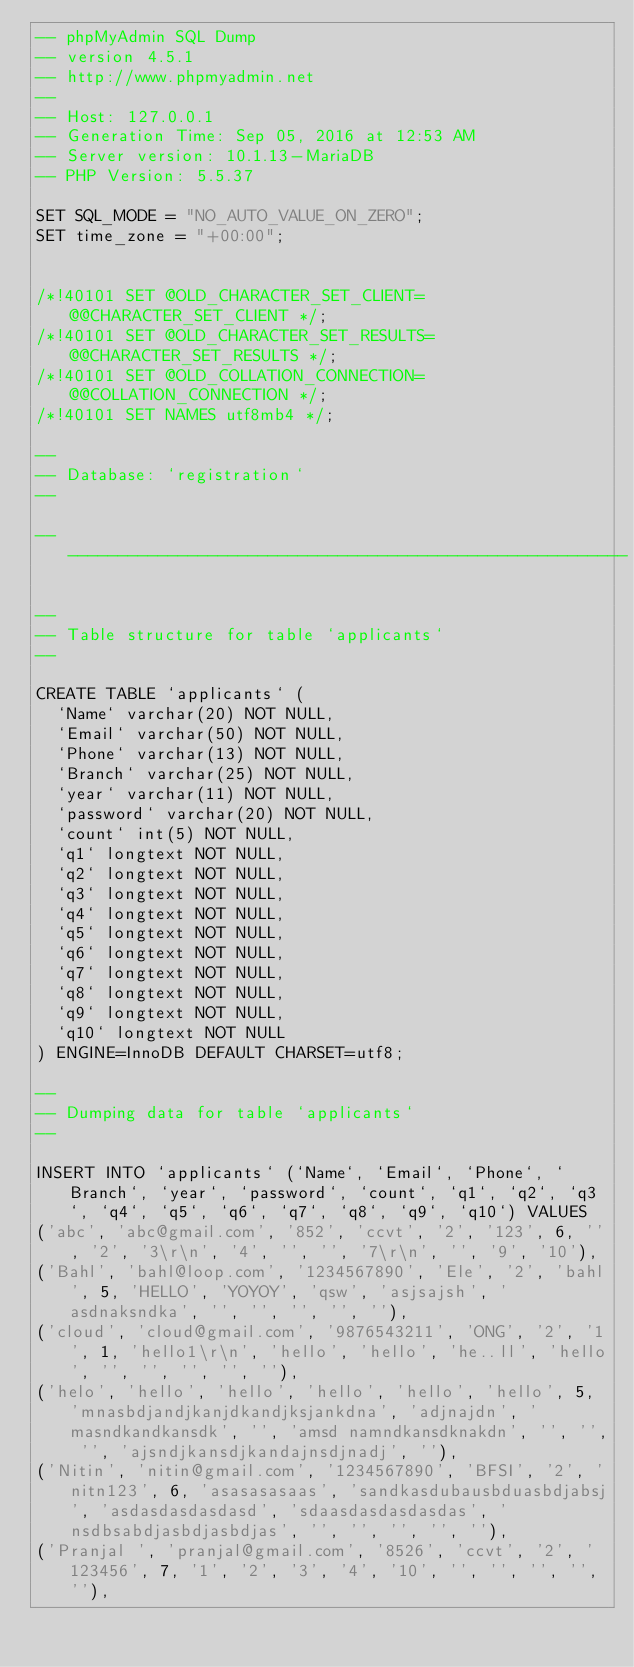Convert code to text. <code><loc_0><loc_0><loc_500><loc_500><_SQL_>-- phpMyAdmin SQL Dump
-- version 4.5.1
-- http://www.phpmyadmin.net
--
-- Host: 127.0.0.1
-- Generation Time: Sep 05, 2016 at 12:53 AM
-- Server version: 10.1.13-MariaDB
-- PHP Version: 5.5.37

SET SQL_MODE = "NO_AUTO_VALUE_ON_ZERO";
SET time_zone = "+00:00";


/*!40101 SET @OLD_CHARACTER_SET_CLIENT=@@CHARACTER_SET_CLIENT */;
/*!40101 SET @OLD_CHARACTER_SET_RESULTS=@@CHARACTER_SET_RESULTS */;
/*!40101 SET @OLD_COLLATION_CONNECTION=@@COLLATION_CONNECTION */;
/*!40101 SET NAMES utf8mb4 */;

--
-- Database: `registration`
--

-- --------------------------------------------------------

--
-- Table structure for table `applicants`
--

CREATE TABLE `applicants` (
  `Name` varchar(20) NOT NULL,
  `Email` varchar(50) NOT NULL,
  `Phone` varchar(13) NOT NULL,
  `Branch` varchar(25) NOT NULL,
  `year` varchar(11) NOT NULL,
  `password` varchar(20) NOT NULL,
  `count` int(5) NOT NULL,
  `q1` longtext NOT NULL,
  `q2` longtext NOT NULL,
  `q3` longtext NOT NULL,
  `q4` longtext NOT NULL,
  `q5` longtext NOT NULL,
  `q6` longtext NOT NULL,
  `q7` longtext NOT NULL,
  `q8` longtext NOT NULL,
  `q9` longtext NOT NULL,
  `q10` longtext NOT NULL
) ENGINE=InnoDB DEFAULT CHARSET=utf8;

--
-- Dumping data for table `applicants`
--

INSERT INTO `applicants` (`Name`, `Email`, `Phone`, `Branch`, `year`, `password`, `count`, `q1`, `q2`, `q3`, `q4`, `q5`, `q6`, `q7`, `q8`, `q9`, `q10`) VALUES
('abc', 'abc@gmail.com', '852', 'ccvt', '2', '123', 6, '', '2', '3\r\n', '4', '', '', '7\r\n', '', '9', '10'),
('Bahl', 'bahl@loop.com', '1234567890', 'Ele', '2', 'bahl', 5, 'HELLO', 'YOYOY', 'qsw', 'asjsajsh', 'asdnaksndka', '', '', '', '', ''),
('cloud', 'cloud@gmail.com', '9876543211', 'ONG', '2', '1', 1, 'hello1\r\n', 'hello', 'hello', 'he..ll', 'hello', '', '', '', '', ''),
('helo', 'hello', 'hello', 'hello', 'hello', 'hello', 5, 'mnasbdjandjkanjdkandjksjankdna', 'adjnajdn', 'masndkandkansdk', '', 'amsd namndkansdknakdn', '', '', '', 'ajsndjkansdjkandajnsdjnadj', ''),
('Nitin', 'nitin@gmail.com', '1234567890', 'BFSI', '2', 'nitn123', 6, 'asasasasaas', 'sandkasdubausbduasbdjabsj', 'asdasdasdasdasd', 'sdaasdasdasdasdas', 'nsdbsabdjasbdjasbdjas', '', '', '', '', ''),
('Pranjal ', 'pranjal@gmail.com', '8526', 'ccvt', '2', '123456', 7, '1', '2', '3', '4', '10', '', '', '', '', ''),</code> 